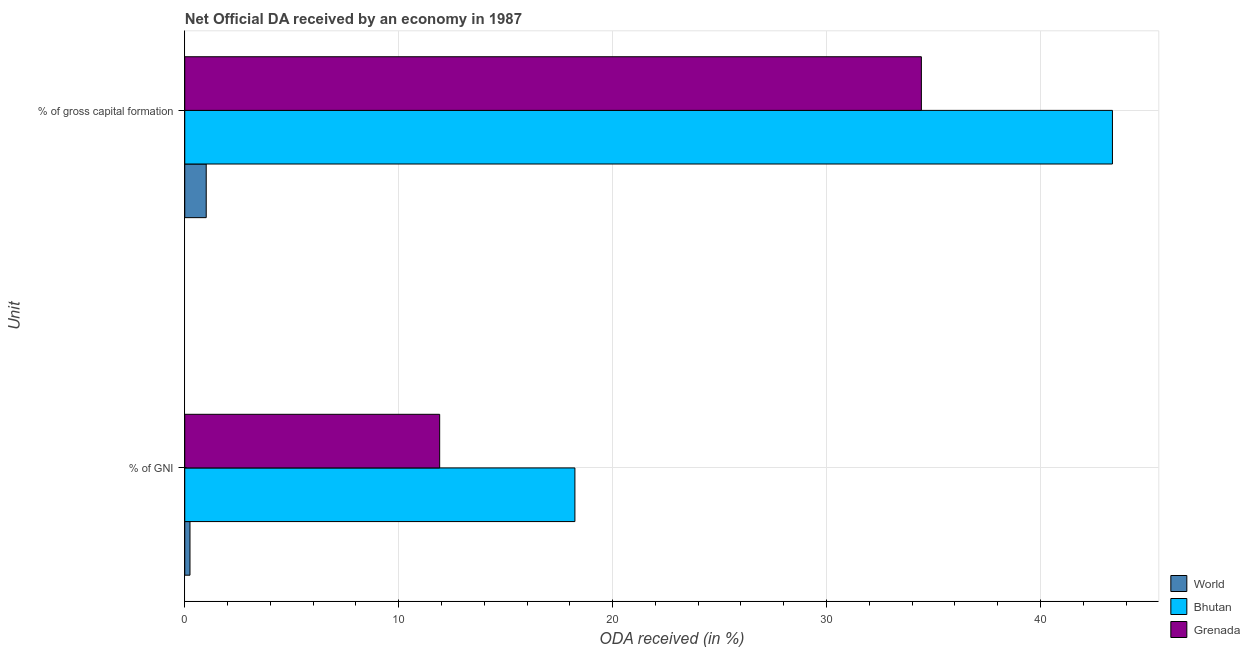How many different coloured bars are there?
Make the answer very short. 3. Are the number of bars on each tick of the Y-axis equal?
Offer a terse response. Yes. How many bars are there on the 1st tick from the bottom?
Offer a very short reply. 3. What is the label of the 1st group of bars from the top?
Make the answer very short. % of gross capital formation. What is the oda received as percentage of gni in World?
Your answer should be very brief. 0.24. Across all countries, what is the maximum oda received as percentage of gross capital formation?
Give a very brief answer. 43.37. Across all countries, what is the minimum oda received as percentage of gross capital formation?
Ensure brevity in your answer.  1. In which country was the oda received as percentage of gross capital formation maximum?
Your answer should be very brief. Bhutan. What is the total oda received as percentage of gross capital formation in the graph?
Your answer should be compact. 78.8. What is the difference between the oda received as percentage of gross capital formation in World and that in Grenada?
Your response must be concise. -33.43. What is the difference between the oda received as percentage of gross capital formation in Grenada and the oda received as percentage of gni in Bhutan?
Your response must be concise. 16.2. What is the average oda received as percentage of gni per country?
Offer a very short reply. 10.13. What is the difference between the oda received as percentage of gni and oda received as percentage of gross capital formation in Bhutan?
Give a very brief answer. -25.13. In how many countries, is the oda received as percentage of gross capital formation greater than 40 %?
Provide a short and direct response. 1. What is the ratio of the oda received as percentage of gross capital formation in Grenada to that in World?
Your answer should be compact. 34.31. Is the oda received as percentage of gross capital formation in Bhutan less than that in Grenada?
Offer a very short reply. No. In how many countries, is the oda received as percentage of gross capital formation greater than the average oda received as percentage of gross capital formation taken over all countries?
Offer a very short reply. 2. What does the 1st bar from the top in % of gross capital formation represents?
Your answer should be compact. Grenada. What does the 3rd bar from the bottom in % of gross capital formation represents?
Keep it short and to the point. Grenada. Are all the bars in the graph horizontal?
Provide a succinct answer. Yes. Does the graph contain grids?
Your answer should be very brief. Yes. How are the legend labels stacked?
Your answer should be very brief. Vertical. What is the title of the graph?
Keep it short and to the point. Net Official DA received by an economy in 1987. What is the label or title of the X-axis?
Your response must be concise. ODA received (in %). What is the label or title of the Y-axis?
Provide a short and direct response. Unit. What is the ODA received (in %) in World in % of GNI?
Make the answer very short. 0.24. What is the ODA received (in %) in Bhutan in % of GNI?
Ensure brevity in your answer.  18.24. What is the ODA received (in %) in Grenada in % of GNI?
Offer a very short reply. 11.92. What is the ODA received (in %) of World in % of gross capital formation?
Provide a succinct answer. 1. What is the ODA received (in %) in Bhutan in % of gross capital formation?
Keep it short and to the point. 43.37. What is the ODA received (in %) in Grenada in % of gross capital formation?
Your answer should be very brief. 34.43. Across all Unit, what is the maximum ODA received (in %) of World?
Provide a short and direct response. 1. Across all Unit, what is the maximum ODA received (in %) in Bhutan?
Your answer should be very brief. 43.37. Across all Unit, what is the maximum ODA received (in %) in Grenada?
Your answer should be compact. 34.43. Across all Unit, what is the minimum ODA received (in %) in World?
Your response must be concise. 0.24. Across all Unit, what is the minimum ODA received (in %) in Bhutan?
Your answer should be very brief. 18.24. Across all Unit, what is the minimum ODA received (in %) of Grenada?
Offer a terse response. 11.92. What is the total ODA received (in %) in World in the graph?
Offer a very short reply. 1.25. What is the total ODA received (in %) in Bhutan in the graph?
Ensure brevity in your answer.  61.6. What is the total ODA received (in %) in Grenada in the graph?
Offer a terse response. 46.35. What is the difference between the ODA received (in %) of World in % of GNI and that in % of gross capital formation?
Your response must be concise. -0.76. What is the difference between the ODA received (in %) in Bhutan in % of GNI and that in % of gross capital formation?
Provide a short and direct response. -25.13. What is the difference between the ODA received (in %) in Grenada in % of GNI and that in % of gross capital formation?
Make the answer very short. -22.52. What is the difference between the ODA received (in %) in World in % of GNI and the ODA received (in %) in Bhutan in % of gross capital formation?
Offer a terse response. -43.12. What is the difference between the ODA received (in %) in World in % of GNI and the ODA received (in %) in Grenada in % of gross capital formation?
Ensure brevity in your answer.  -34.19. What is the difference between the ODA received (in %) in Bhutan in % of GNI and the ODA received (in %) in Grenada in % of gross capital formation?
Your response must be concise. -16.2. What is the average ODA received (in %) in World per Unit?
Your answer should be very brief. 0.62. What is the average ODA received (in %) in Bhutan per Unit?
Provide a succinct answer. 30.8. What is the average ODA received (in %) in Grenada per Unit?
Offer a terse response. 23.18. What is the difference between the ODA received (in %) of World and ODA received (in %) of Bhutan in % of GNI?
Your response must be concise. -17.99. What is the difference between the ODA received (in %) of World and ODA received (in %) of Grenada in % of GNI?
Provide a succinct answer. -11.67. What is the difference between the ODA received (in %) in Bhutan and ODA received (in %) in Grenada in % of GNI?
Your answer should be compact. 6.32. What is the difference between the ODA received (in %) of World and ODA received (in %) of Bhutan in % of gross capital formation?
Provide a succinct answer. -42.36. What is the difference between the ODA received (in %) of World and ODA received (in %) of Grenada in % of gross capital formation?
Offer a very short reply. -33.43. What is the difference between the ODA received (in %) in Bhutan and ODA received (in %) in Grenada in % of gross capital formation?
Your answer should be very brief. 8.93. What is the ratio of the ODA received (in %) in World in % of GNI to that in % of gross capital formation?
Ensure brevity in your answer.  0.24. What is the ratio of the ODA received (in %) of Bhutan in % of GNI to that in % of gross capital formation?
Ensure brevity in your answer.  0.42. What is the ratio of the ODA received (in %) in Grenada in % of GNI to that in % of gross capital formation?
Ensure brevity in your answer.  0.35. What is the difference between the highest and the second highest ODA received (in %) in World?
Keep it short and to the point. 0.76. What is the difference between the highest and the second highest ODA received (in %) in Bhutan?
Ensure brevity in your answer.  25.13. What is the difference between the highest and the second highest ODA received (in %) of Grenada?
Give a very brief answer. 22.52. What is the difference between the highest and the lowest ODA received (in %) in World?
Your answer should be very brief. 0.76. What is the difference between the highest and the lowest ODA received (in %) of Bhutan?
Keep it short and to the point. 25.13. What is the difference between the highest and the lowest ODA received (in %) in Grenada?
Keep it short and to the point. 22.52. 